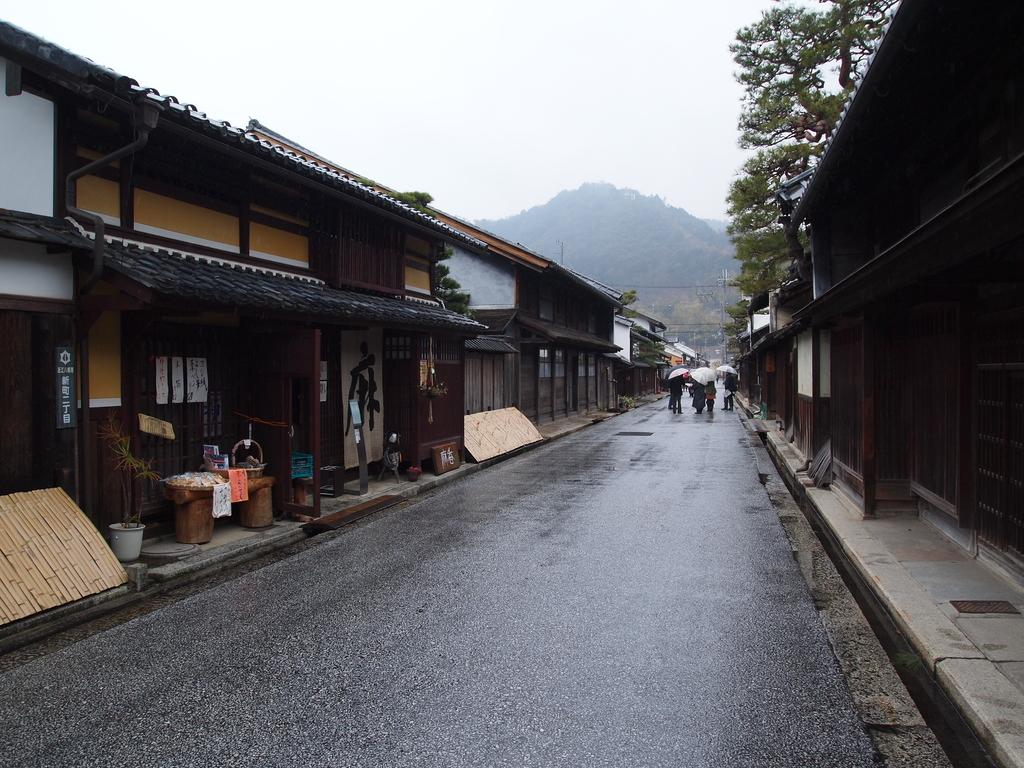What type of structures can be seen in the image? There are sheds in the image. What are the people in the image using to protect themselves from the weather? People are holding umbrellas in the image. What is the main pathway visible in the image? There is a road in the image. What type of natural features can be seen in the background of the image? There are trees and hills in the background of the image. What is visible in the sky in the image? The sky is visible in the background of the image. What type of clam is being used as a doorstop for the sheds in the image? There are no clams present in the image, and therefore no clams are being used as doorstops. How many rings can be seen on the trees in the image? There are no rings visible on the trees in the image. 